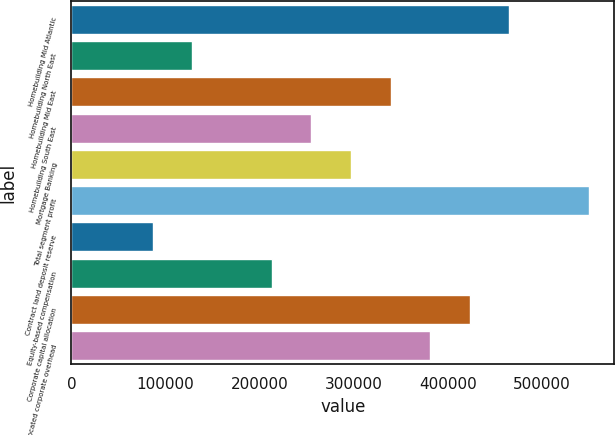Convert chart. <chart><loc_0><loc_0><loc_500><loc_500><bar_chart><fcel>Homebuilding Mid Atlantic<fcel>Homebuilding North East<fcel>Homebuilding Mid East<fcel>Homebuilding South East<fcel>Mortgage Banking<fcel>Total segment profit<fcel>Contract land deposit reserve<fcel>Equity-based compensation<fcel>Corporate capital allocation<fcel>Unallocated corporate overhead<nl><fcel>465400<fcel>128645<fcel>339117<fcel>254928<fcel>297023<fcel>549589<fcel>86550.8<fcel>212834<fcel>423306<fcel>381212<nl></chart> 